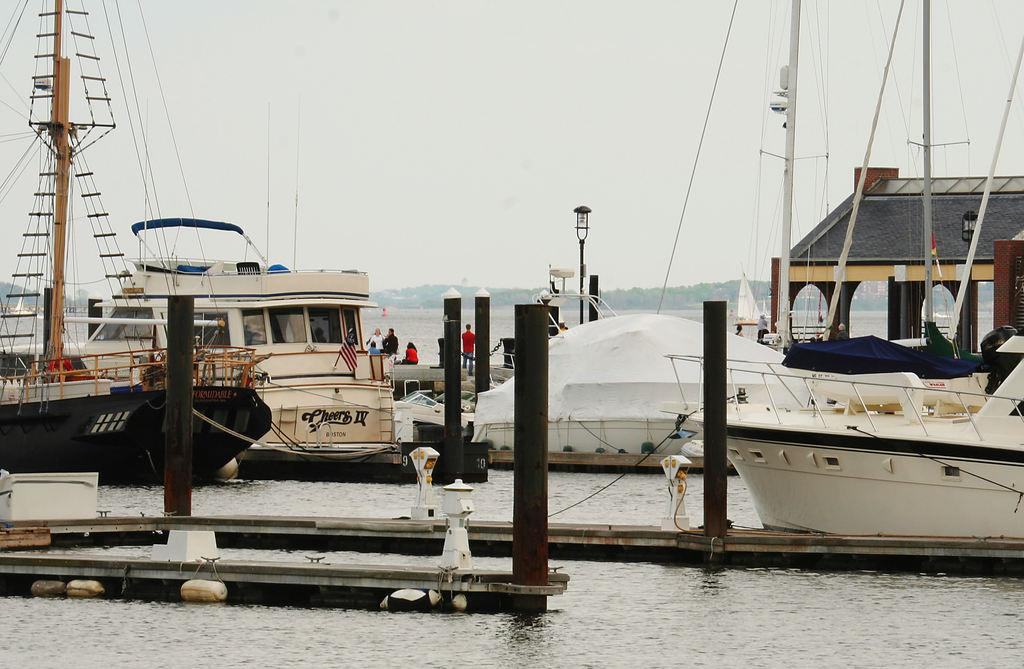What is in the water in the image? There are ships in the water. What is visible at the top of the image? The sky is visible at the top of the image. Where is the volleyball being played in the image? There is no volleyball present in the image. What is covering the feet of the people in the image? There are no people present in the image, so it is not possible to determine what might be covering their feet. 